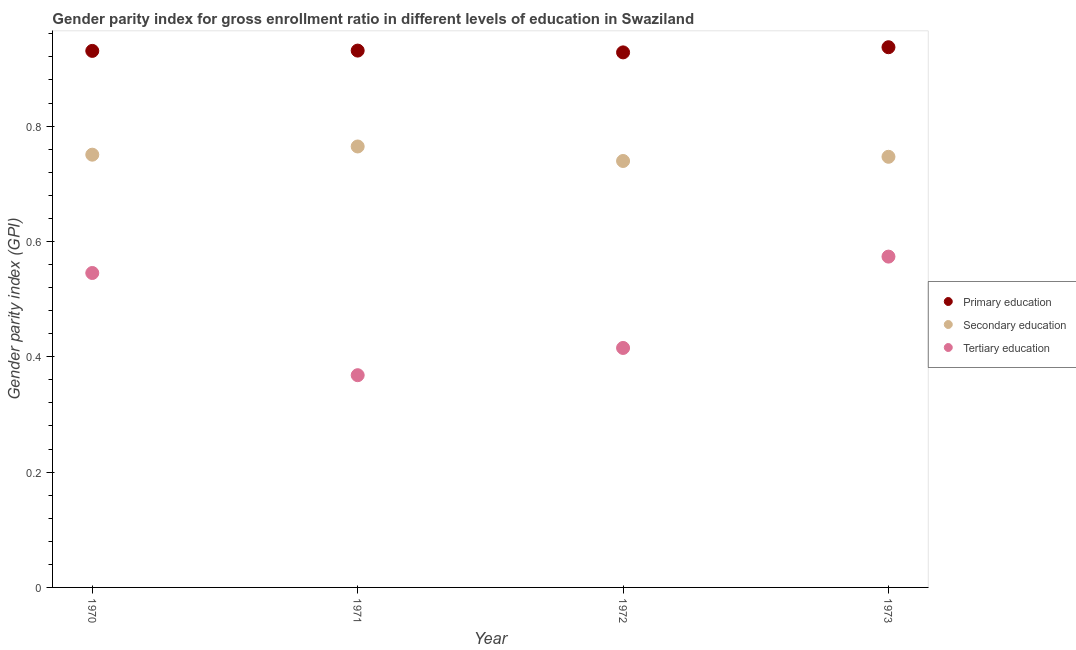How many different coloured dotlines are there?
Make the answer very short. 3. What is the gender parity index in primary education in 1971?
Offer a very short reply. 0.93. Across all years, what is the maximum gender parity index in secondary education?
Make the answer very short. 0.76. Across all years, what is the minimum gender parity index in tertiary education?
Make the answer very short. 0.37. In which year was the gender parity index in secondary education minimum?
Your answer should be compact. 1972. What is the total gender parity index in tertiary education in the graph?
Keep it short and to the point. 1.9. What is the difference between the gender parity index in tertiary education in 1971 and that in 1973?
Your response must be concise. -0.21. What is the difference between the gender parity index in tertiary education in 1970 and the gender parity index in secondary education in 1971?
Make the answer very short. -0.22. What is the average gender parity index in secondary education per year?
Your response must be concise. 0.75. In the year 1971, what is the difference between the gender parity index in primary education and gender parity index in tertiary education?
Provide a short and direct response. 0.56. In how many years, is the gender parity index in tertiary education greater than 0.6400000000000001?
Keep it short and to the point. 0. What is the ratio of the gender parity index in secondary education in 1972 to that in 1973?
Offer a very short reply. 0.99. Is the gender parity index in secondary education in 1972 less than that in 1973?
Your answer should be very brief. Yes. Is the difference between the gender parity index in tertiary education in 1971 and 1973 greater than the difference between the gender parity index in primary education in 1971 and 1973?
Your answer should be very brief. No. What is the difference between the highest and the second highest gender parity index in tertiary education?
Your answer should be compact. 0.03. What is the difference between the highest and the lowest gender parity index in primary education?
Your response must be concise. 0.01. In how many years, is the gender parity index in primary education greater than the average gender parity index in primary education taken over all years?
Give a very brief answer. 1. Is the sum of the gender parity index in tertiary education in 1971 and 1972 greater than the maximum gender parity index in primary education across all years?
Give a very brief answer. No. Does the graph contain grids?
Your answer should be very brief. No. Where does the legend appear in the graph?
Make the answer very short. Center right. How many legend labels are there?
Offer a very short reply. 3. What is the title of the graph?
Give a very brief answer. Gender parity index for gross enrollment ratio in different levels of education in Swaziland. What is the label or title of the Y-axis?
Give a very brief answer. Gender parity index (GPI). What is the Gender parity index (GPI) in Primary education in 1970?
Offer a terse response. 0.93. What is the Gender parity index (GPI) of Secondary education in 1970?
Your answer should be compact. 0.75. What is the Gender parity index (GPI) in Tertiary education in 1970?
Provide a succinct answer. 0.55. What is the Gender parity index (GPI) of Primary education in 1971?
Your answer should be very brief. 0.93. What is the Gender parity index (GPI) of Secondary education in 1971?
Your answer should be very brief. 0.76. What is the Gender parity index (GPI) in Tertiary education in 1971?
Offer a very short reply. 0.37. What is the Gender parity index (GPI) in Primary education in 1972?
Provide a short and direct response. 0.93. What is the Gender parity index (GPI) in Secondary education in 1972?
Offer a terse response. 0.74. What is the Gender parity index (GPI) in Tertiary education in 1972?
Your response must be concise. 0.42. What is the Gender parity index (GPI) of Primary education in 1973?
Make the answer very short. 0.94. What is the Gender parity index (GPI) in Secondary education in 1973?
Your answer should be compact. 0.75. What is the Gender parity index (GPI) of Tertiary education in 1973?
Provide a succinct answer. 0.57. Across all years, what is the maximum Gender parity index (GPI) in Primary education?
Keep it short and to the point. 0.94. Across all years, what is the maximum Gender parity index (GPI) of Secondary education?
Offer a terse response. 0.76. Across all years, what is the maximum Gender parity index (GPI) in Tertiary education?
Make the answer very short. 0.57. Across all years, what is the minimum Gender parity index (GPI) in Primary education?
Give a very brief answer. 0.93. Across all years, what is the minimum Gender parity index (GPI) of Secondary education?
Make the answer very short. 0.74. Across all years, what is the minimum Gender parity index (GPI) of Tertiary education?
Keep it short and to the point. 0.37. What is the total Gender parity index (GPI) in Primary education in the graph?
Keep it short and to the point. 3.73. What is the total Gender parity index (GPI) of Secondary education in the graph?
Your answer should be compact. 3. What is the total Gender parity index (GPI) of Tertiary education in the graph?
Your answer should be very brief. 1.9. What is the difference between the Gender parity index (GPI) in Primary education in 1970 and that in 1971?
Provide a short and direct response. -0. What is the difference between the Gender parity index (GPI) of Secondary education in 1970 and that in 1971?
Offer a terse response. -0.01. What is the difference between the Gender parity index (GPI) in Tertiary education in 1970 and that in 1971?
Give a very brief answer. 0.18. What is the difference between the Gender parity index (GPI) of Primary education in 1970 and that in 1972?
Make the answer very short. 0. What is the difference between the Gender parity index (GPI) of Secondary education in 1970 and that in 1972?
Ensure brevity in your answer.  0.01. What is the difference between the Gender parity index (GPI) in Tertiary education in 1970 and that in 1972?
Offer a terse response. 0.13. What is the difference between the Gender parity index (GPI) of Primary education in 1970 and that in 1973?
Give a very brief answer. -0.01. What is the difference between the Gender parity index (GPI) of Secondary education in 1970 and that in 1973?
Provide a succinct answer. 0. What is the difference between the Gender parity index (GPI) of Tertiary education in 1970 and that in 1973?
Provide a succinct answer. -0.03. What is the difference between the Gender parity index (GPI) of Primary education in 1971 and that in 1972?
Your answer should be very brief. 0. What is the difference between the Gender parity index (GPI) in Secondary education in 1971 and that in 1972?
Give a very brief answer. 0.03. What is the difference between the Gender parity index (GPI) in Tertiary education in 1971 and that in 1972?
Provide a succinct answer. -0.05. What is the difference between the Gender parity index (GPI) of Primary education in 1971 and that in 1973?
Your answer should be very brief. -0.01. What is the difference between the Gender parity index (GPI) of Secondary education in 1971 and that in 1973?
Make the answer very short. 0.02. What is the difference between the Gender parity index (GPI) in Tertiary education in 1971 and that in 1973?
Make the answer very short. -0.21. What is the difference between the Gender parity index (GPI) in Primary education in 1972 and that in 1973?
Provide a short and direct response. -0.01. What is the difference between the Gender parity index (GPI) in Secondary education in 1972 and that in 1973?
Offer a very short reply. -0.01. What is the difference between the Gender parity index (GPI) of Tertiary education in 1972 and that in 1973?
Provide a succinct answer. -0.16. What is the difference between the Gender parity index (GPI) of Primary education in 1970 and the Gender parity index (GPI) of Secondary education in 1971?
Your answer should be very brief. 0.17. What is the difference between the Gender parity index (GPI) of Primary education in 1970 and the Gender parity index (GPI) of Tertiary education in 1971?
Offer a very short reply. 0.56. What is the difference between the Gender parity index (GPI) in Secondary education in 1970 and the Gender parity index (GPI) in Tertiary education in 1971?
Keep it short and to the point. 0.38. What is the difference between the Gender parity index (GPI) in Primary education in 1970 and the Gender parity index (GPI) in Secondary education in 1972?
Ensure brevity in your answer.  0.19. What is the difference between the Gender parity index (GPI) of Primary education in 1970 and the Gender parity index (GPI) of Tertiary education in 1972?
Your answer should be compact. 0.52. What is the difference between the Gender parity index (GPI) in Secondary education in 1970 and the Gender parity index (GPI) in Tertiary education in 1972?
Your response must be concise. 0.34. What is the difference between the Gender parity index (GPI) in Primary education in 1970 and the Gender parity index (GPI) in Secondary education in 1973?
Your response must be concise. 0.18. What is the difference between the Gender parity index (GPI) of Primary education in 1970 and the Gender parity index (GPI) of Tertiary education in 1973?
Your answer should be very brief. 0.36. What is the difference between the Gender parity index (GPI) in Secondary education in 1970 and the Gender parity index (GPI) in Tertiary education in 1973?
Offer a terse response. 0.18. What is the difference between the Gender parity index (GPI) in Primary education in 1971 and the Gender parity index (GPI) in Secondary education in 1972?
Provide a short and direct response. 0.19. What is the difference between the Gender parity index (GPI) in Primary education in 1971 and the Gender parity index (GPI) in Tertiary education in 1972?
Provide a succinct answer. 0.52. What is the difference between the Gender parity index (GPI) in Secondary education in 1971 and the Gender parity index (GPI) in Tertiary education in 1972?
Give a very brief answer. 0.35. What is the difference between the Gender parity index (GPI) in Primary education in 1971 and the Gender parity index (GPI) in Secondary education in 1973?
Give a very brief answer. 0.18. What is the difference between the Gender parity index (GPI) of Primary education in 1971 and the Gender parity index (GPI) of Tertiary education in 1973?
Offer a terse response. 0.36. What is the difference between the Gender parity index (GPI) in Secondary education in 1971 and the Gender parity index (GPI) in Tertiary education in 1973?
Provide a short and direct response. 0.19. What is the difference between the Gender parity index (GPI) of Primary education in 1972 and the Gender parity index (GPI) of Secondary education in 1973?
Ensure brevity in your answer.  0.18. What is the difference between the Gender parity index (GPI) of Primary education in 1972 and the Gender parity index (GPI) of Tertiary education in 1973?
Make the answer very short. 0.35. What is the difference between the Gender parity index (GPI) in Secondary education in 1972 and the Gender parity index (GPI) in Tertiary education in 1973?
Make the answer very short. 0.17. What is the average Gender parity index (GPI) in Primary education per year?
Make the answer very short. 0.93. What is the average Gender parity index (GPI) in Secondary education per year?
Provide a short and direct response. 0.75. What is the average Gender parity index (GPI) in Tertiary education per year?
Your response must be concise. 0.48. In the year 1970, what is the difference between the Gender parity index (GPI) in Primary education and Gender parity index (GPI) in Secondary education?
Give a very brief answer. 0.18. In the year 1970, what is the difference between the Gender parity index (GPI) of Primary education and Gender parity index (GPI) of Tertiary education?
Offer a very short reply. 0.39. In the year 1970, what is the difference between the Gender parity index (GPI) in Secondary education and Gender parity index (GPI) in Tertiary education?
Keep it short and to the point. 0.21. In the year 1971, what is the difference between the Gender parity index (GPI) in Primary education and Gender parity index (GPI) in Secondary education?
Make the answer very short. 0.17. In the year 1971, what is the difference between the Gender parity index (GPI) of Primary education and Gender parity index (GPI) of Tertiary education?
Your answer should be compact. 0.56. In the year 1971, what is the difference between the Gender parity index (GPI) of Secondary education and Gender parity index (GPI) of Tertiary education?
Keep it short and to the point. 0.4. In the year 1972, what is the difference between the Gender parity index (GPI) in Primary education and Gender parity index (GPI) in Secondary education?
Your answer should be compact. 0.19. In the year 1972, what is the difference between the Gender parity index (GPI) of Primary education and Gender parity index (GPI) of Tertiary education?
Provide a succinct answer. 0.51. In the year 1972, what is the difference between the Gender parity index (GPI) of Secondary education and Gender parity index (GPI) of Tertiary education?
Your answer should be very brief. 0.32. In the year 1973, what is the difference between the Gender parity index (GPI) in Primary education and Gender parity index (GPI) in Secondary education?
Your response must be concise. 0.19. In the year 1973, what is the difference between the Gender parity index (GPI) of Primary education and Gender parity index (GPI) of Tertiary education?
Offer a terse response. 0.36. In the year 1973, what is the difference between the Gender parity index (GPI) of Secondary education and Gender parity index (GPI) of Tertiary education?
Make the answer very short. 0.17. What is the ratio of the Gender parity index (GPI) of Secondary education in 1970 to that in 1971?
Offer a very short reply. 0.98. What is the ratio of the Gender parity index (GPI) in Tertiary education in 1970 to that in 1971?
Your response must be concise. 1.48. What is the ratio of the Gender parity index (GPI) of Primary education in 1970 to that in 1972?
Keep it short and to the point. 1. What is the ratio of the Gender parity index (GPI) in Secondary education in 1970 to that in 1972?
Offer a terse response. 1.01. What is the ratio of the Gender parity index (GPI) in Tertiary education in 1970 to that in 1972?
Your answer should be compact. 1.31. What is the ratio of the Gender parity index (GPI) of Secondary education in 1970 to that in 1973?
Keep it short and to the point. 1. What is the ratio of the Gender parity index (GPI) in Tertiary education in 1970 to that in 1973?
Give a very brief answer. 0.95. What is the ratio of the Gender parity index (GPI) of Primary education in 1971 to that in 1972?
Give a very brief answer. 1. What is the ratio of the Gender parity index (GPI) in Secondary education in 1971 to that in 1972?
Ensure brevity in your answer.  1.03. What is the ratio of the Gender parity index (GPI) in Tertiary education in 1971 to that in 1972?
Your answer should be very brief. 0.89. What is the ratio of the Gender parity index (GPI) of Primary education in 1971 to that in 1973?
Give a very brief answer. 0.99. What is the ratio of the Gender parity index (GPI) in Tertiary education in 1971 to that in 1973?
Offer a very short reply. 0.64. What is the ratio of the Gender parity index (GPI) of Primary education in 1972 to that in 1973?
Your answer should be compact. 0.99. What is the ratio of the Gender parity index (GPI) of Secondary education in 1972 to that in 1973?
Your answer should be very brief. 0.99. What is the ratio of the Gender parity index (GPI) in Tertiary education in 1972 to that in 1973?
Your response must be concise. 0.72. What is the difference between the highest and the second highest Gender parity index (GPI) in Primary education?
Give a very brief answer. 0.01. What is the difference between the highest and the second highest Gender parity index (GPI) of Secondary education?
Provide a succinct answer. 0.01. What is the difference between the highest and the second highest Gender parity index (GPI) in Tertiary education?
Your answer should be compact. 0.03. What is the difference between the highest and the lowest Gender parity index (GPI) of Primary education?
Offer a terse response. 0.01. What is the difference between the highest and the lowest Gender parity index (GPI) of Secondary education?
Ensure brevity in your answer.  0.03. What is the difference between the highest and the lowest Gender parity index (GPI) of Tertiary education?
Provide a short and direct response. 0.21. 